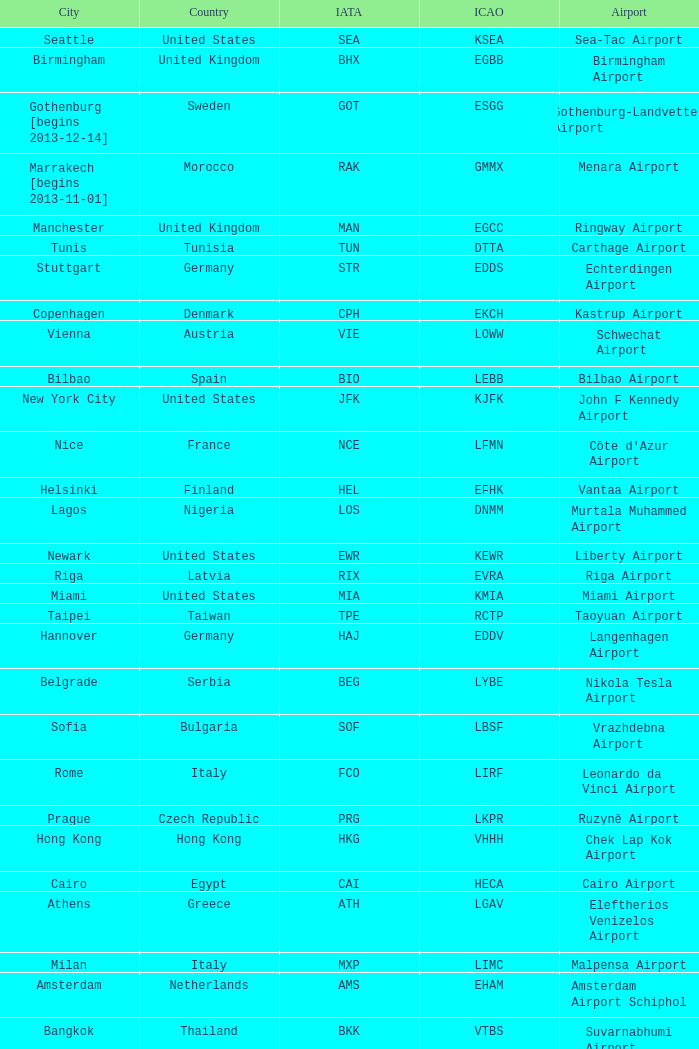Which city has the IATA SSG? Malabo. 